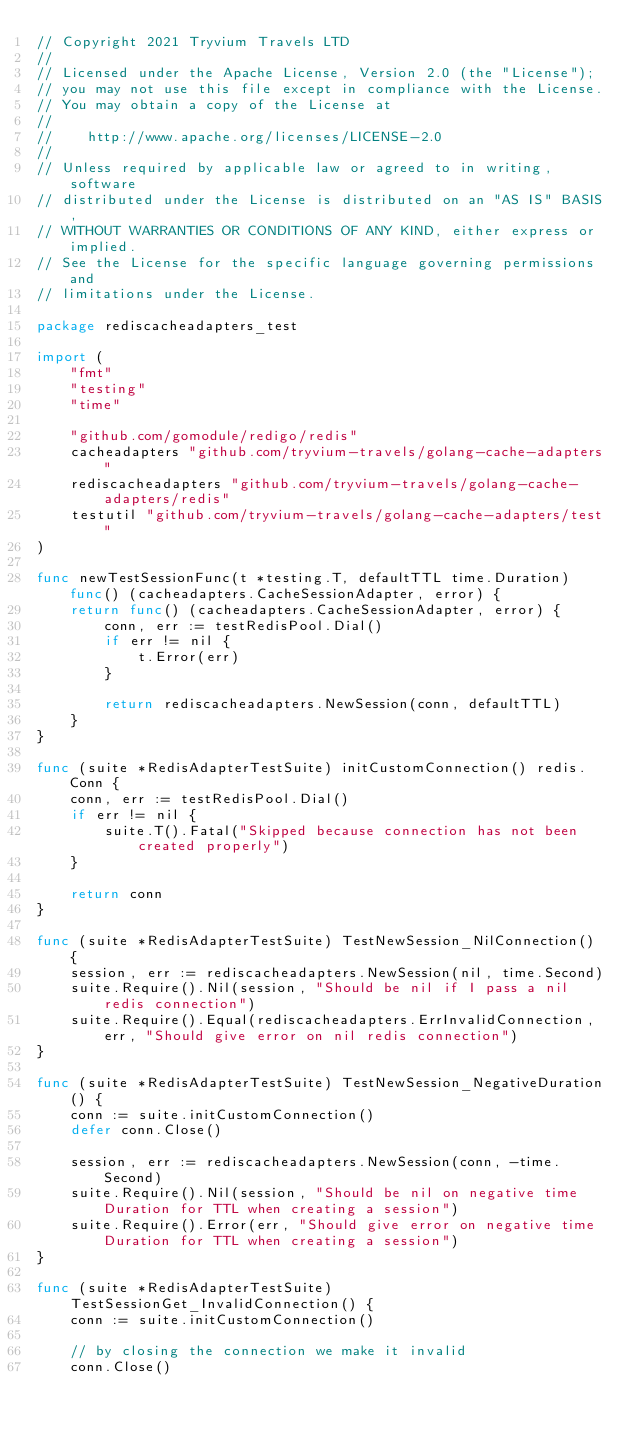<code> <loc_0><loc_0><loc_500><loc_500><_Go_>// Copyright 2021 Tryvium Travels LTD
//
// Licensed under the Apache License, Version 2.0 (the "License");
// you may not use this file except in compliance with the License.
// You may obtain a copy of the License at
//
//    http://www.apache.org/licenses/LICENSE-2.0
//
// Unless required by applicable law or agreed to in writing, software
// distributed under the License is distributed on an "AS IS" BASIS,
// WITHOUT WARRANTIES OR CONDITIONS OF ANY KIND, either express or implied.
// See the License for the specific language governing permissions and
// limitations under the License.

package rediscacheadapters_test

import (
	"fmt"
	"testing"
	"time"

	"github.com/gomodule/redigo/redis"
	cacheadapters "github.com/tryvium-travels/golang-cache-adapters"
	rediscacheadapters "github.com/tryvium-travels/golang-cache-adapters/redis"
	testutil "github.com/tryvium-travels/golang-cache-adapters/test"
)

func newTestSessionFunc(t *testing.T, defaultTTL time.Duration) func() (cacheadapters.CacheSessionAdapter, error) {
	return func() (cacheadapters.CacheSessionAdapter, error) {
		conn, err := testRedisPool.Dial()
		if err != nil {
			t.Error(err)
		}

		return rediscacheadapters.NewSession(conn, defaultTTL)
	}
}

func (suite *RedisAdapterTestSuite) initCustomConnection() redis.Conn {
	conn, err := testRedisPool.Dial()
	if err != nil {
		suite.T().Fatal("Skipped because connection has not been created properly")
	}

	return conn
}

func (suite *RedisAdapterTestSuite) TestNewSession_NilConnection() {
	session, err := rediscacheadapters.NewSession(nil, time.Second)
	suite.Require().Nil(session, "Should be nil if I pass a nil redis connection")
	suite.Require().Equal(rediscacheadapters.ErrInvalidConnection, err, "Should give error on nil redis connection")
}

func (suite *RedisAdapterTestSuite) TestNewSession_NegativeDuration() {
	conn := suite.initCustomConnection()
	defer conn.Close()

	session, err := rediscacheadapters.NewSession(conn, -time.Second)
	suite.Require().Nil(session, "Should be nil on negative time Duration for TTL when creating a session")
	suite.Require().Error(err, "Should give error on negative time Duration for TTL when creating a session")
}

func (suite *RedisAdapterTestSuite) TestSessionGet_InvalidConnection() {
	conn := suite.initCustomConnection()

	// by closing the connection we make it invalid
	conn.Close()
</code> 